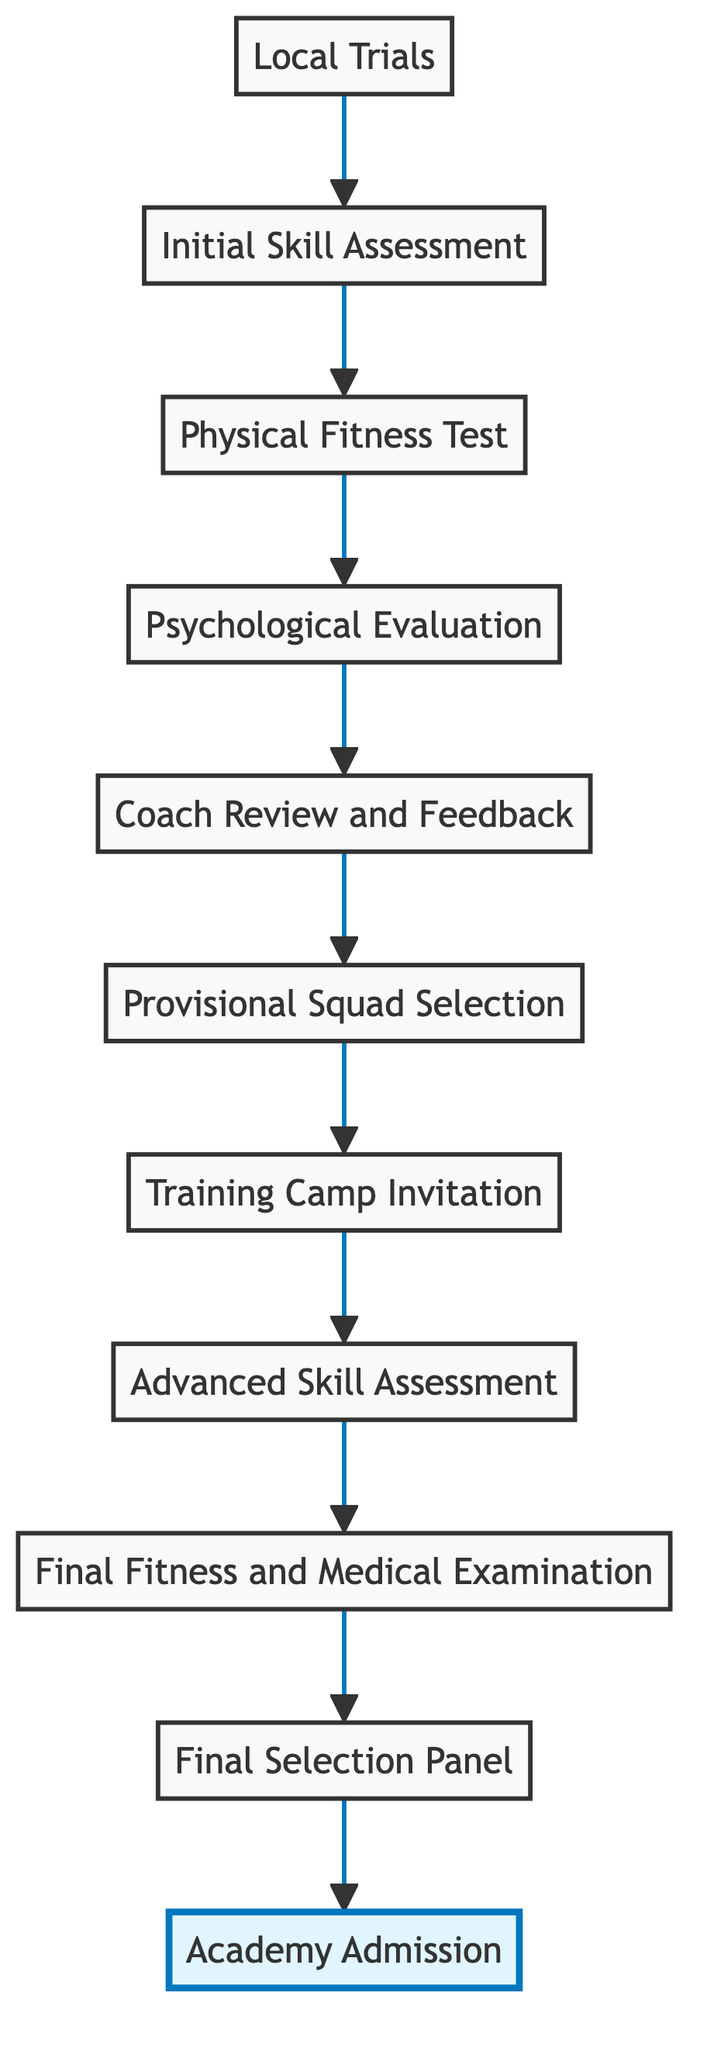What is the starting point of the process? The diagram begins with the first node labeled "Local Trials," indicating the initial stage for talent identification.
Answer: Local Trials What is the final step in the process? The last node in the flowchart is "Academy Admission," which signifies the successful conclusion for selected candidates.
Answer: Academy Admission How many evaluation steps are there before the final selection panel? Counting the nodes from "Initial Skill Assessment" to "Final Selection Panel," there are 8 evaluation steps in total.
Answer: 8 Which process follows the "Provisional Squad Selection"? The next step after "Provisional Squad Selection" is "Training Camp Invitation," leading to the more detailed evaluation phase.
Answer: Training Camp Invitation What type of assessment is conducted after the "Physical Fitness Test"? The "Psychological Evaluation" comes next, assessing the candidates' mental attributes post-physical fitness evaluation.
Answer: Psychological Evaluation What is the direct relationship between "Training Camp Invitation" and "Advanced Skill Assessment"? They have a direct sequential relationship, with "Training Camp Invitation" leading directly into the "Advanced Skill Assessment" phase.
Answer: Direct sequential relationship What must candidates undergo before the "Final Selection Panel"? Candidates must complete the "Final Fitness and Medical Examination" prior to reaching the decision of the "Final Selection Panel."
Answer: Final Fitness and Medical Examination How many nodes in total are there in the flowchart? Counting each unique step from "Local Trials" to "Academy Admission," the flowchart contains 11 nodes.
Answer: 11 What key aspect is reviewed in the "Coach Review and Feedback" stage? The key aspect is the performance evaluation and feedback from coaches to determine the top candidates.
Answer: Performance evaluation and feedback What step involves in-depth evaluation of skills? The "Advanced Skill Assessment" stage focuses on a thorough evaluation of both technical and tactical skills.
Answer: Advanced Skill Assessment 